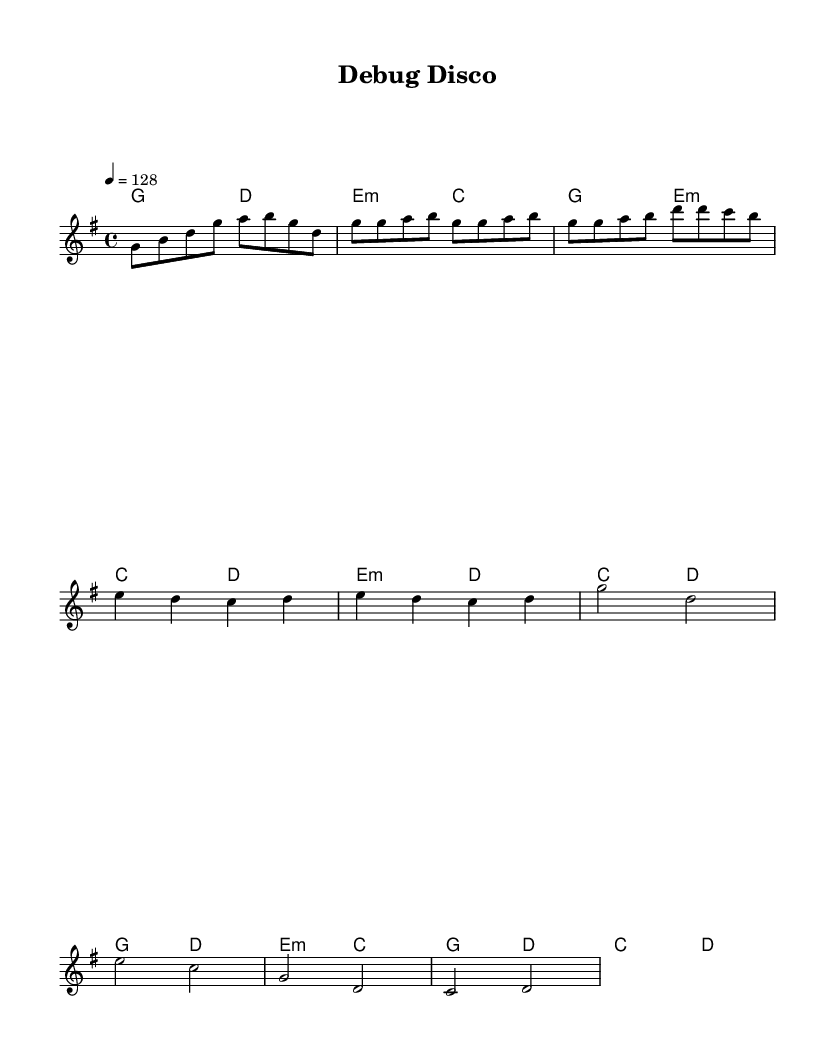What is the key signature of this music? The key signature is G major, which has one sharp (F#) indicated at the beginning of the staff.
Answer: G major What is the time signature of this music? The time signature is indicated by the numbers written at the beginning of the staff as 4 over 4, which means there are four beats in each measure.
Answer: 4/4 What is the tempo marking of this music? The tempo marking is located above the staff and shows a speed of 128 beats per minute, indicated by "4 = 128."
Answer: 128 How many measures are there in the chorus section? To find the number of measures, we count the measures in the chorus portion of the sheet music, which has four distinct measures.
Answer: 4 What is the starting note of the melody? The starting note of the melody is the first note in the melody section, which is G, indicating that the piece begins on this note.
Answer: G What type of musical piece is exemplified by this sheet music? This sheet music exemplifies a K-Pop style due to its upbeat tempo and danceable rhythm, typical of high-energy K-Pop tracks.
Answer: K-Pop What lyric theme is present in the pre-chorus of the music? The pre-chorus emphasizes resilience in facing challenges while coding, indicating a theme of perseverance against errors during debugging.
Answer: Perseverance 